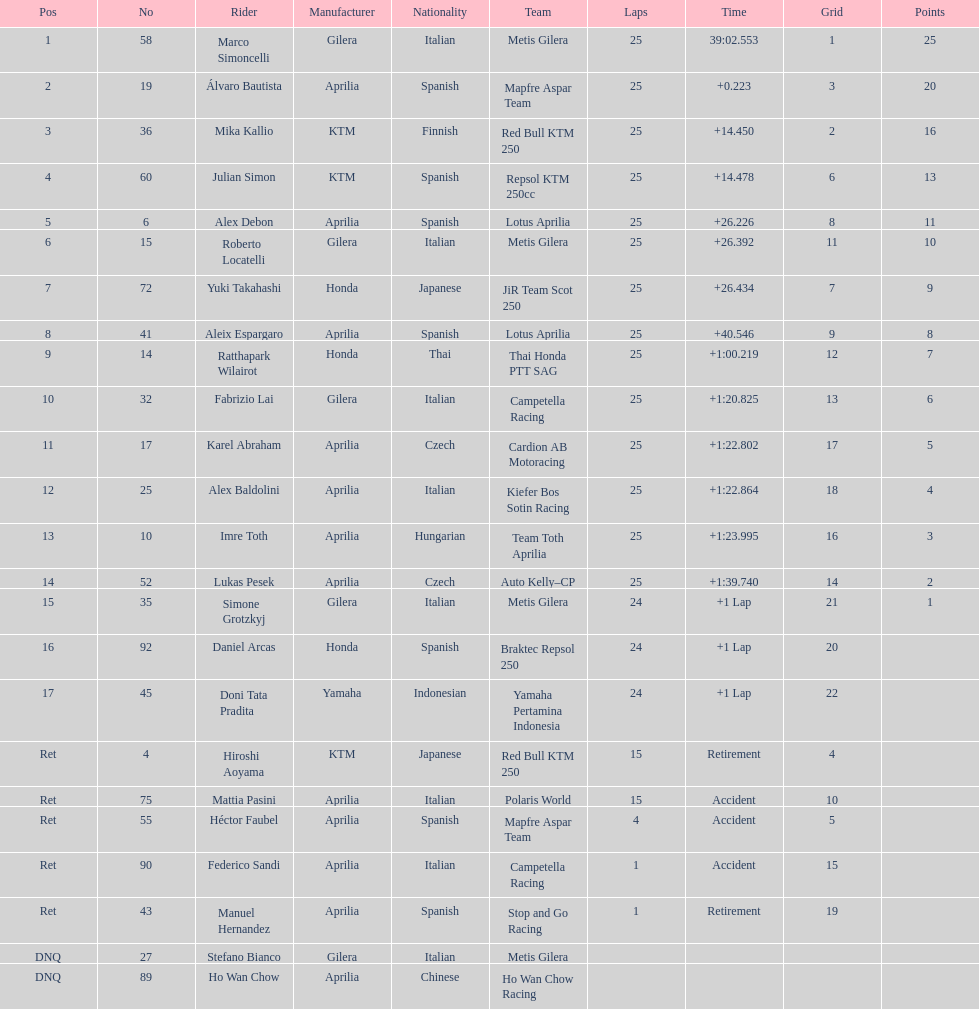The next rider from italy aside from winner marco simoncelli was Roberto Locatelli. 